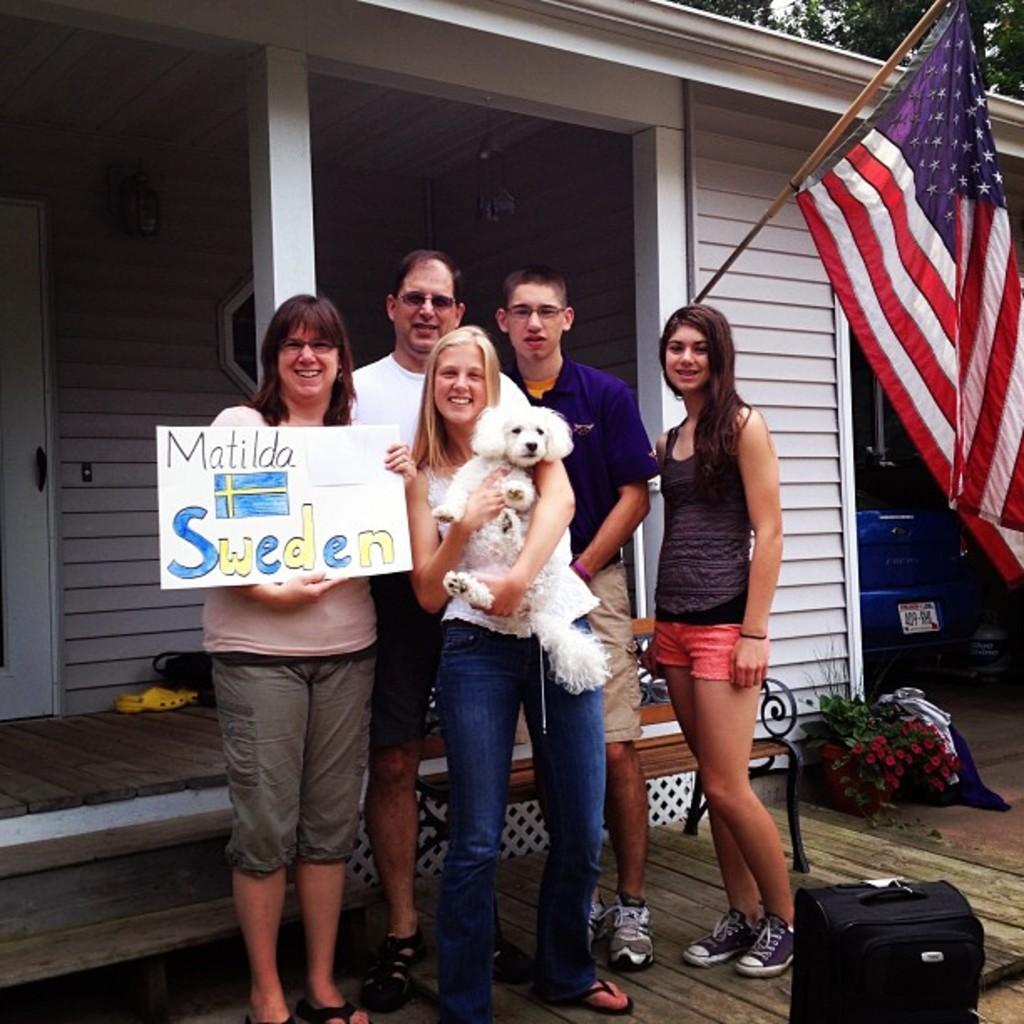How would you summarize this image in a sentence or two? This image is clicked outside the house. There are five people in this image. In the front, the women wearing white dress is holding a white dog. To the right, there is a flag. In the background, there is a house. To the bottom right, there is a bag. 